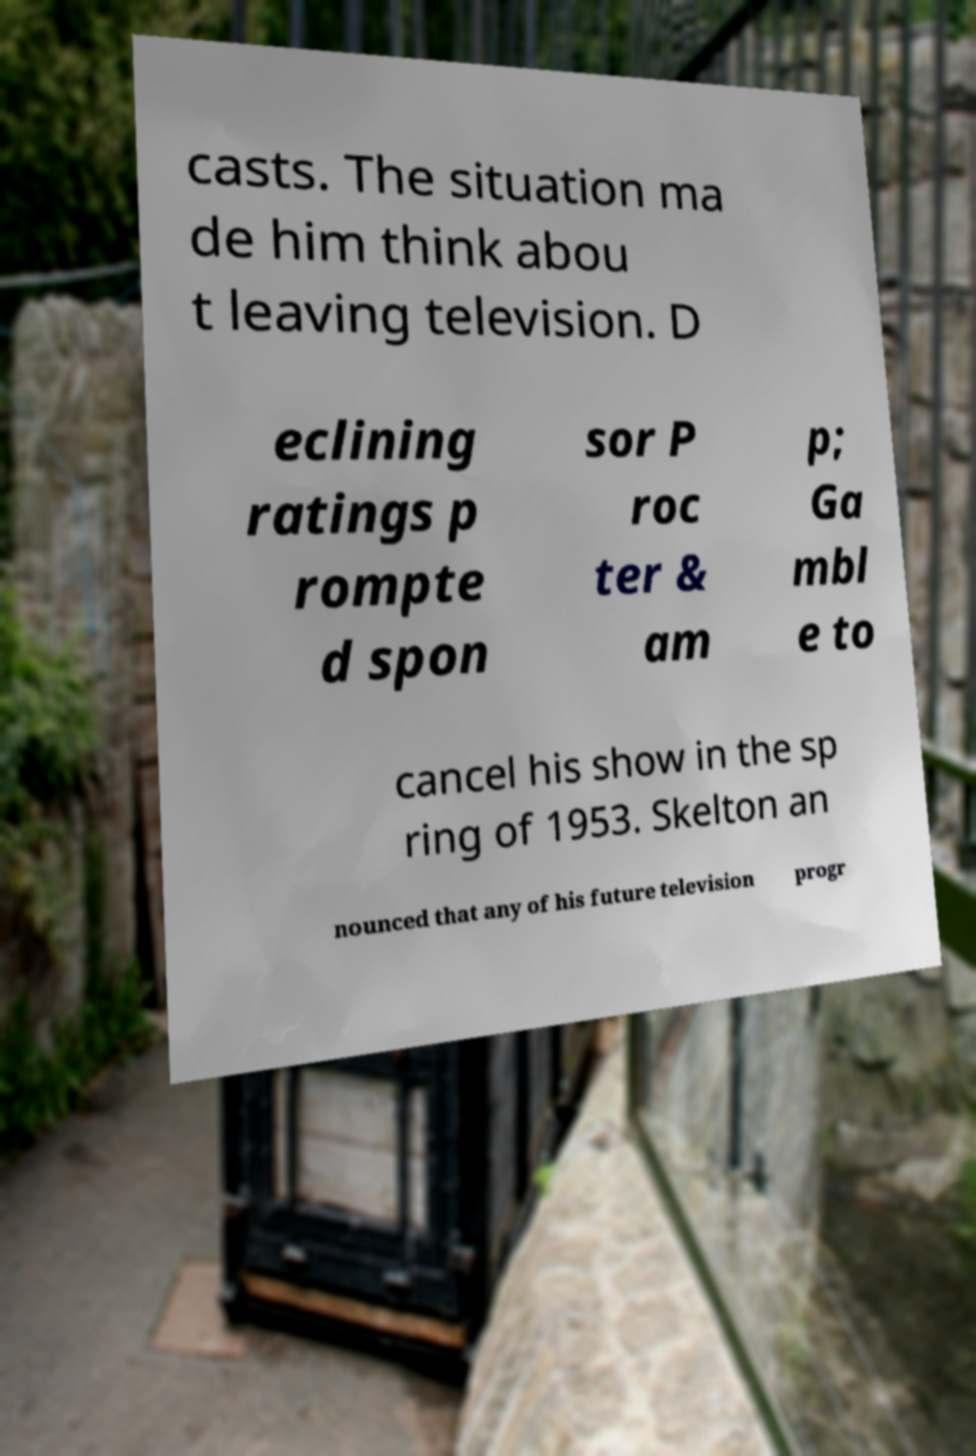Could you assist in decoding the text presented in this image and type it out clearly? casts. The situation ma de him think abou t leaving television. D eclining ratings p rompte d spon sor P roc ter & am p; Ga mbl e to cancel his show in the sp ring of 1953. Skelton an nounced that any of his future television progr 